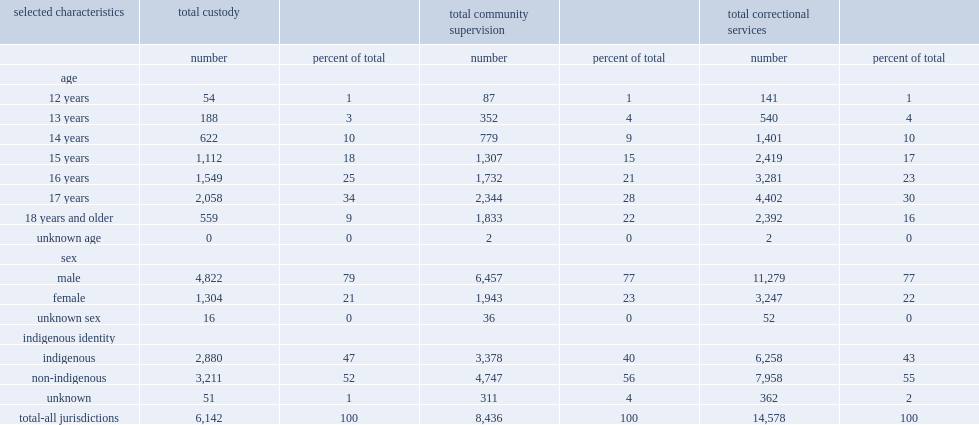Would you mind parsing the complete table? {'header': ['selected characteristics', 'total custody', '', 'total community supervision', '', 'total correctional services', ''], 'rows': [['', 'number', 'percent of total', 'number', 'percent of total', 'number', 'percent of total'], ['age', '', '', '', '', '', ''], ['12 years', '54', '1', '87', '1', '141', '1'], ['13 years', '188', '3', '352', '4', '540', '4'], ['14 years', '622', '10', '779', '9', '1,401', '10'], ['15 years', '1,112', '18', '1,307', '15', '2,419', '17'], ['16 years', '1,549', '25', '1,732', '21', '3,281', '23'], ['17 years', '2,058', '34', '2,344', '28', '4,402', '30'], ['18 years and older', '559', '9', '1,833', '22', '2,392', '16'], ['unknown age', '0', '0', '2', '0', '2', '0'], ['sex', '', '', '', '', '', ''], ['male', '4,822', '79', '6,457', '77', '11,279', '77'], ['female', '1,304', '21', '1,943', '23', '3,247', '22'], ['unknown sex', '16', '0', '36', '0', '52', '0'], ['indigenous identity', '', '', '', '', '', ''], ['indigenous', '2,880', '47', '3,378', '40', '6,258', '43'], ['non-indigenous', '3,211', '52', '4,747', '56', '7,958', '55'], ['unknown', '51', '1', '311', '4', '362', '2'], ['total-all jurisdictions', '6,142', '100', '8,436', '100', '14,578', '100']]} What was the percentage of indigenous youth representing youth admissions to correctional services in 2018/2019 ? 43.0. What were the percentages of indigenous youth representing youth admissions to custody and community supervision in 2018/2019 respectively? 47.0 40.0. What was the percentage of young male admitted into correctional services in 2018/2019? 77.0. What were the percentages of young male admitted into custody and community supervision in 2018/2019 respectively? 79.0 77.0. What was the percentage of youth admissions to correctional services in 2018/2019 aged 16 to 17 at the time of admission? 53. What was the percentage of youth admissions to custody in 2018/2019 aged 16 to 17 at the time of admission? 59. 